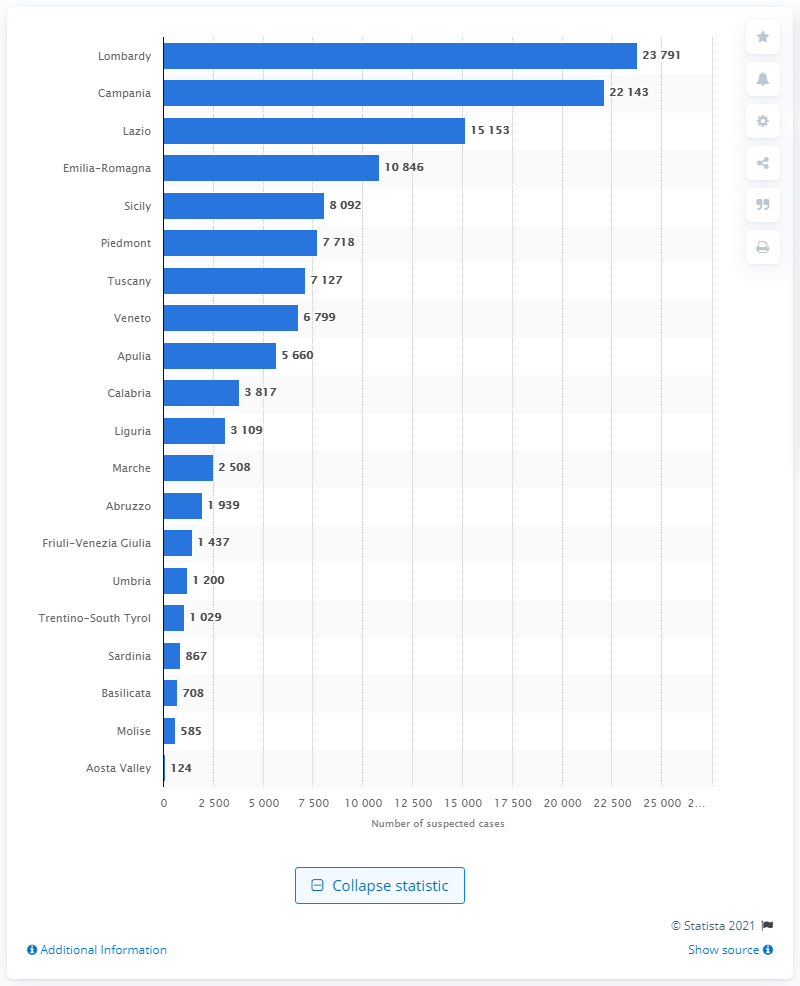Where was the largest number of suspected financial operations reported in Italy in 2019? In 2019, the region of Lombardy reported the highest number of suspected financial operations in Italy, with a staggering 23,791 cases, significantly more than the second-highest region, Campania, which reported 22,143 cases. 